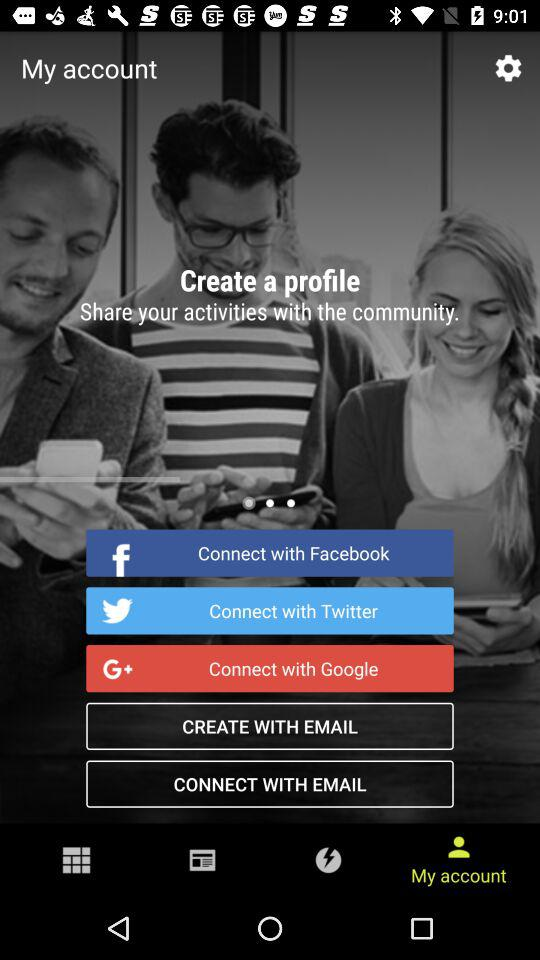What is the number of articles in "Science"? The number of articles in "Science" is 74. 